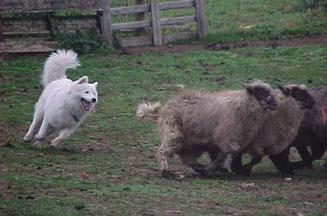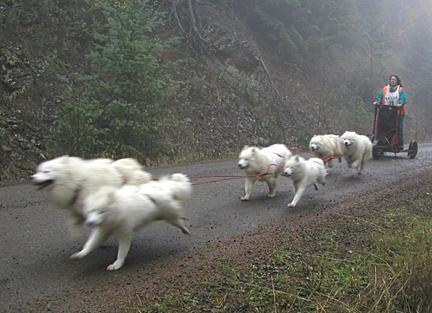The first image is the image on the left, the second image is the image on the right. Considering the images on both sides, is "There is a woman standing and facing right." valid? Answer yes or no. No. The first image is the image on the left, the second image is the image on the right. Evaluate the accuracy of this statement regarding the images: "In one image, a dog is with a person and sheep.". Is it true? Answer yes or no. No. 